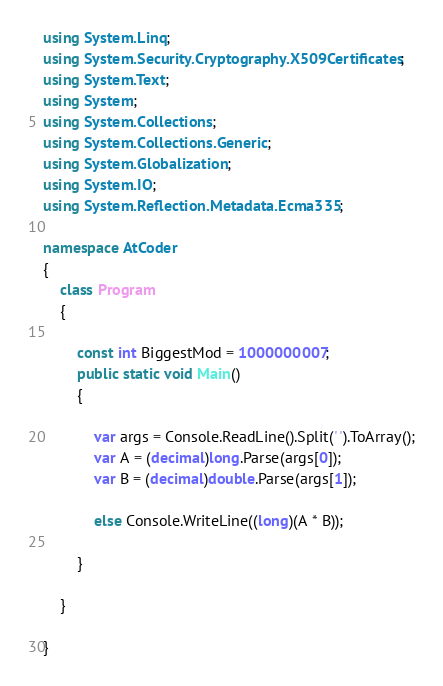Convert code to text. <code><loc_0><loc_0><loc_500><loc_500><_C#_>using System.Linq;
using System.Security.Cryptography.X509Certificates;
using System.Text;
using System;
using System.Collections;
using System.Collections.Generic;
using System.Globalization;
using System.IO;
using System.Reflection.Metadata.Ecma335;

namespace AtCoder
{
    class Program
    {

        const int BiggestMod = 1000000007;
        public static void Main()
        {

            var args = Console.ReadLine().Split(' ').ToArray();
            var A = (decimal)long.Parse(args[0]);
            var B = (decimal)double.Parse(args[1]);

            else Console.WriteLine((long)(A * B));

        }

    }

}
</code> 